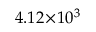<formula> <loc_0><loc_0><loc_500><loc_500>4 . 1 2 \, \times \, 1 0 ^ { 3 }</formula> 